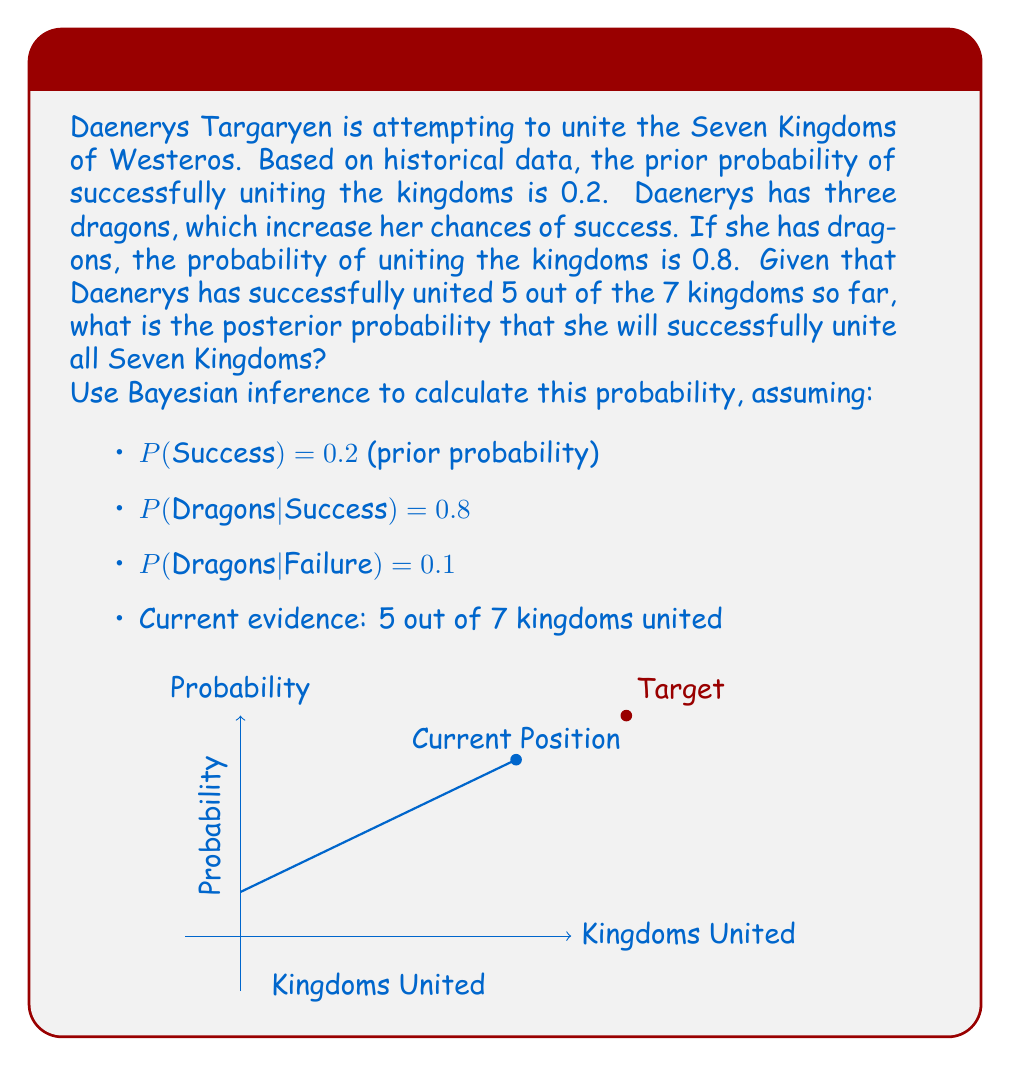Could you help me with this problem? Let's approach this step-by-step using Bayes' theorem:

1) Define our events:
   S: Successfully uniting all Seven Kingdoms
   D: Having dragons
   E: Current evidence (5 out of 7 kingdoms united)

2) We want to find P(S|E), the probability of success given the current evidence.

3) Bayes' theorem states:
   $$P(S|E) = \frac{P(E|S) \cdot P(S)}{P(E)}$$

4) We know P(S) = 0.2 (prior probability of success)

5) To calculate P(E|S), we can use the binomial probability:
   $$P(E|S) = \binom{7}{5} \cdot 0.8^5 \cdot 0.2^2 = 0.2369$$

6) To calculate P(E), we need to consider both success and failure scenarios:
   $$P(E) = P(E|S) \cdot P(S) + P(E|F) \cdot P(F)$$
   
   Where F is the event of failure, and P(F) = 1 - P(S) = 0.8

7) We calculate P(E|F) similarly:
   $$P(E|F) = \binom{7}{5} \cdot 0.2^5 \cdot 0.8^2 = 0.0014$$

8) Now we can calculate P(E):
   $$P(E) = 0.2369 \cdot 0.2 + 0.0014 \cdot 0.8 = 0.0485$$

9) Putting it all together in Bayes' theorem:
   $$P(S|E) = \frac{0.2369 \cdot 0.2}{0.0485} = 0.9773$$

Therefore, the posterior probability that Daenerys will successfully unite all Seven Kingdoms, given the current evidence, is approximately 0.9773 or 97.73%.
Answer: 0.9773 